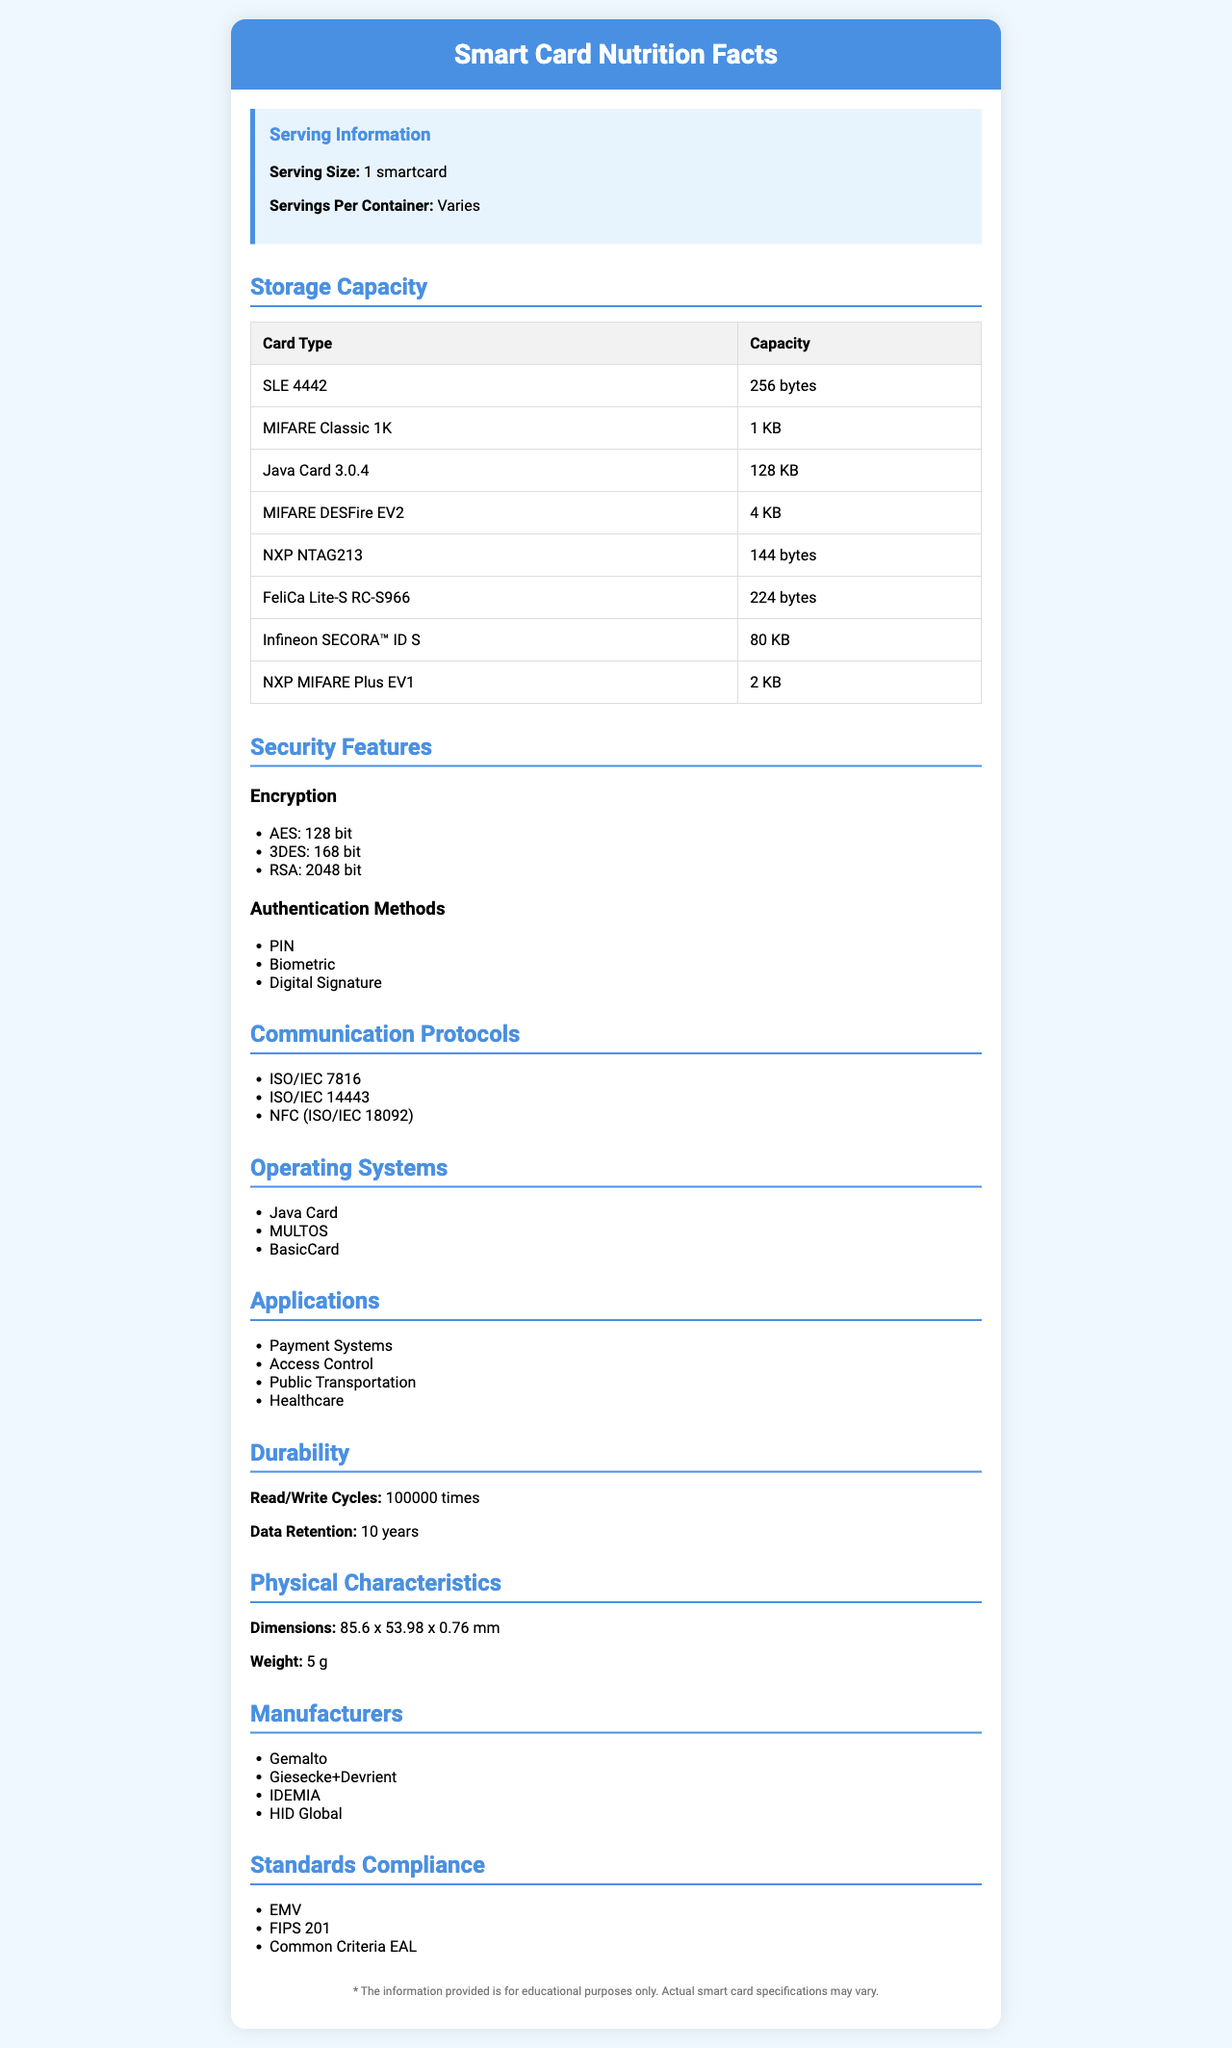what is the storage capacity of the Java Card 3.0.4? The storage capacity of the Java Card 3.0.4 is listed as 128 KB under "Contact Smart Cards".
Answer: 128 KB which smart card has the smallest storage capacity among Contactless Smart Cards? FeliCa Lite-S RC-S966 has a storage capacity of 224 bytes, which is the smallest listed under "Contactless Smart Cards".
Answer: FeliCa Lite-S RC-S966 name two manufacturers listed in the document Two manufacturers listed in the document under "Manufacturer" are Gemalto and HID Global.
Answer: Gemalto, HID Global how long is the data retention time for smart cards? The data retention time is specified as 10 years under "Durability".
Answer: 10 years what is the typical dimension of a smart card in this document? The typical dimensions listed under "Physical Characteristics" are 85.6 mm in length, 53.98 mm in width, and 0.76 mm in thickness.
Answer: 85.6 x 53.98 x 0.76 mm which of the following smart cards has the highest storage capacity?
A. SLE 4442
B. MIFARE DESFire EV2
C. Java Card 3.0.4 
D. NXP MIFARE Plus EV1 The Java Card 3.0.4 has a storage capacity of 128 KB, which is the highest among the given options under "Storage Capacity".
Answer: Java Card 3.0.4 what are the authentication methods mentioned in the document?
I. PIN
II. Password
III. Biometric
IV. Digital Signature The authentication methods listed are PIN, Biometric, and Digital Signature under "Security Features".
Answer: I, III, IV are MIFARE Classic 1K and NXP NTAG213 both contactless smart cards? MIFARE Classic 1K is listed under "Contact Smart Cards", while NXP NTAG213 is listed under "Contactless Smart Cards".
Answer: No summarize the main idea of the document The document is a detailed overview of smart card specifications, presenting data on their storage capacities, security features, communication protocols, operating systems, various applications, durability, physical characteristics, manufacturers, and compliance with standards.
Answer: The document provides comprehensive information about various attributes of smart cards, such as storage capacities, security features, communication protocols, operating systems, applications, durability, physical characteristics, manufacturers, and standards compliance what is the maximum number of read/write cycles for the smart cards? Under "Durability", it is stated that the maximum number of read/write cycles is 100,000 times.
Answer: 100,000 times what kind of encryption is used in the smart cards?
A. AES
B. 3DES
C. RSA
D. All of the above The document lists AES, 3DES, and RSA as types of encryption used under "Security Features".
Answer: D. All of the above what is the memory unit for Infineon SECORA™ ID S? The memory unit for Infineon SECORA™ ID S is KB, as listed under "Dual Interface Cards".
Answer: KB What is the weight of the smart card in grams? Under "Physical Characteristics", the weight is specified as 5 grams.
Answer: 5 grams Which standard is not mentioned in the document as standards compliance? A. EMV B. FIPS 201 C. ISO 8583 The document mentions EMV, FIPS 201, and Common Criteria EAL, but not ISO 8583 under "Standards Compliance".
Answer: C. ISO 8583 Is the NTAG213 a type of Dual Interface Card? NXP NTAG213 is listed under "Contactless Smart Cards", not under "Dual Interface Cards".
Answer: No Why is the manufacturer list important for this document? The document lists manufacturers, but it does not provide enough information to determine why this list is important.
Answer: Not enough information 